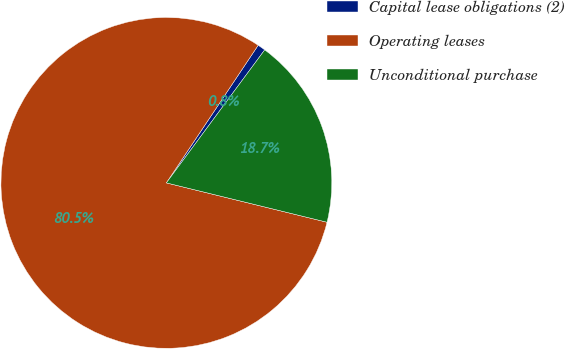Convert chart to OTSL. <chart><loc_0><loc_0><loc_500><loc_500><pie_chart><fcel>Capital lease obligations (2)<fcel>Operating leases<fcel>Unconditional purchase<nl><fcel>0.77%<fcel>80.54%<fcel>18.69%<nl></chart> 